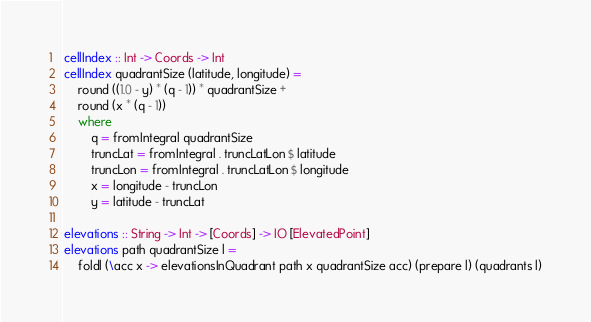<code> <loc_0><loc_0><loc_500><loc_500><_Haskell_>cellIndex :: Int -> Coords -> Int
cellIndex quadrantSize (latitude, longitude) = 
	round ((1.0 - y) * (q - 1)) * quadrantSize +
	round (x * (q - 1))
	where
		q = fromIntegral quadrantSize
		truncLat = fromIntegral . truncLatLon $ latitude
		truncLon = fromIntegral . truncLatLon $ longitude
		x = longitude - truncLon
		y = latitude - truncLat

elevations :: String -> Int -> [Coords] -> IO [ElevatedPoint]
elevations path quadrantSize l = 
	foldl (\acc x -> elevationsInQuadrant path x quadrantSize acc) (prepare l) (quadrants l)

</code> 